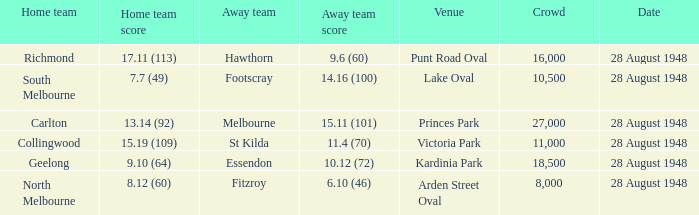What home team has a team score of 8.12 (60)? North Melbourne. Give me the full table as a dictionary. {'header': ['Home team', 'Home team score', 'Away team', 'Away team score', 'Venue', 'Crowd', 'Date'], 'rows': [['Richmond', '17.11 (113)', 'Hawthorn', '9.6 (60)', 'Punt Road Oval', '16,000', '28 August 1948'], ['South Melbourne', '7.7 (49)', 'Footscray', '14.16 (100)', 'Lake Oval', '10,500', '28 August 1948'], ['Carlton', '13.14 (92)', 'Melbourne', '15.11 (101)', 'Princes Park', '27,000', '28 August 1948'], ['Collingwood', '15.19 (109)', 'St Kilda', '11.4 (70)', 'Victoria Park', '11,000', '28 August 1948'], ['Geelong', '9.10 (64)', 'Essendon', '10.12 (72)', 'Kardinia Park', '18,500', '28 August 1948'], ['North Melbourne', '8.12 (60)', 'Fitzroy', '6.10 (46)', 'Arden Street Oval', '8,000', '28 August 1948']]} 